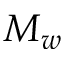Convert formula to latex. <formula><loc_0><loc_0><loc_500><loc_500>M _ { w }</formula> 